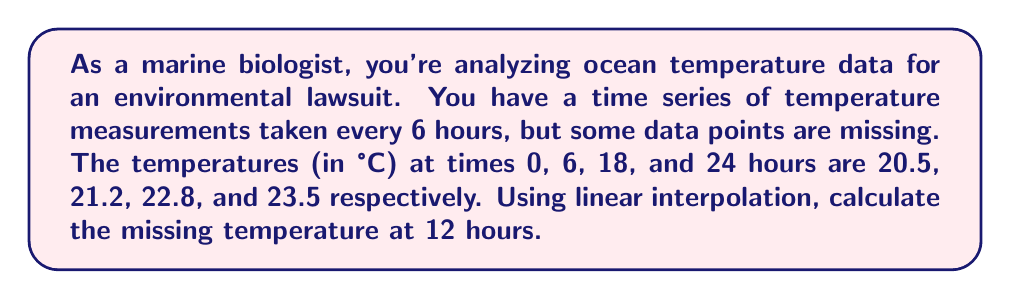Give your solution to this math problem. To solve this problem, we'll use linear interpolation to estimate the missing temperature at 12 hours. Linear interpolation assumes a linear relationship between known data points.

1) We have two sets of known points that surround our target time:
   $(t_1, T_1) = (6, 21.2)$ and $(t_2, T_2) = (18, 22.8)$

2) The formula for linear interpolation is:

   $$T = T_1 + \frac{(t - t_1)(T_2 - T_1)}{(t_2 - t_1)}$$

   Where:
   $T$ is the interpolated temperature
   $t$ is the time we're interpolating for (12 hours)
   $t_1, T_1$ are the time and temperature of the first known point
   $t_2, T_2$ are the time and temperature of the second known point

3) Let's substitute our values:

   $$T = 21.2 + \frac{(12 - 6)(22.8 - 21.2)}{(18 - 6)}$$

4) Simplify:

   $$T = 21.2 + \frac{6(1.6)}{12} = 21.2 + \frac{9.6}{12}$$

5) Calculate:

   $$T = 21.2 + 0.8 = 22.0$$

Therefore, the interpolated temperature at 12 hours is 22.0°C.
Answer: 22.0°C 